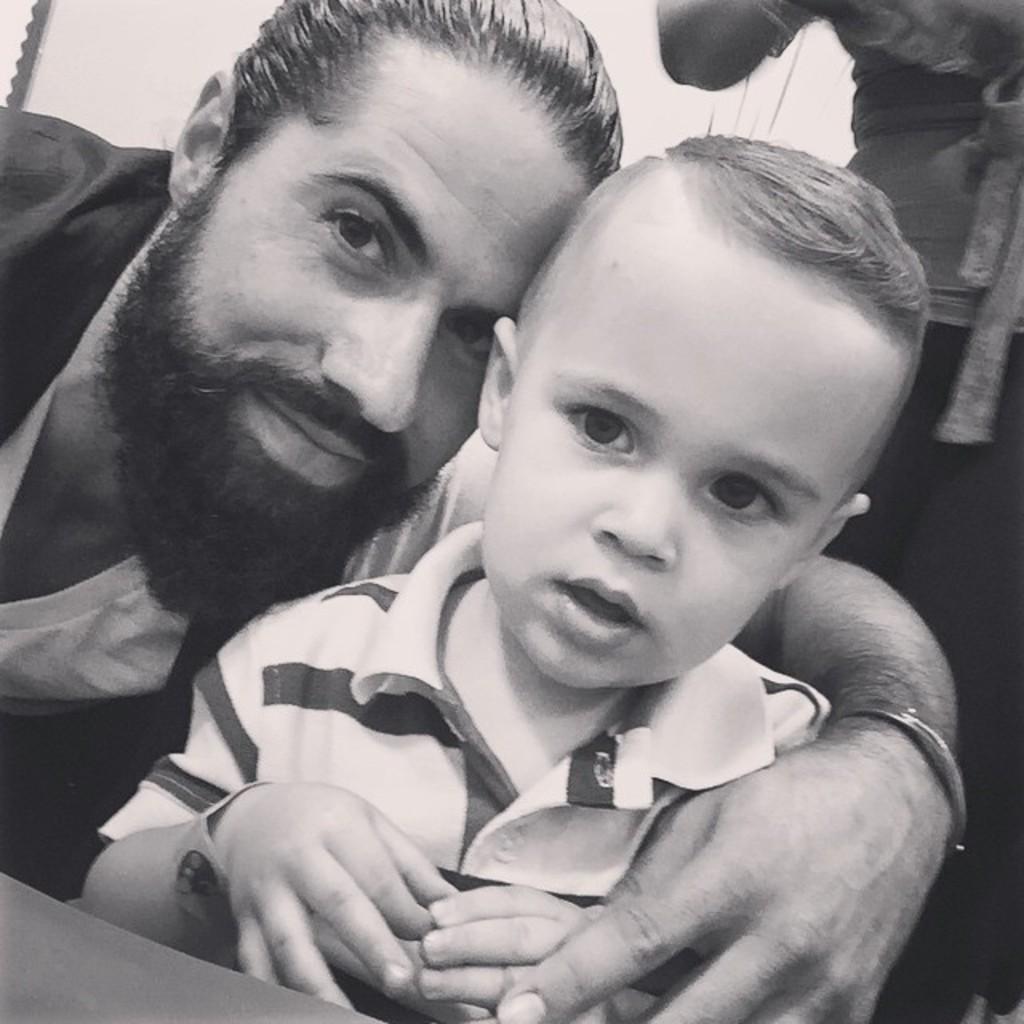Describe this image in one or two sentences. This is a black and white picture. Here we can see a man and a kid. In the background we can see a person. 